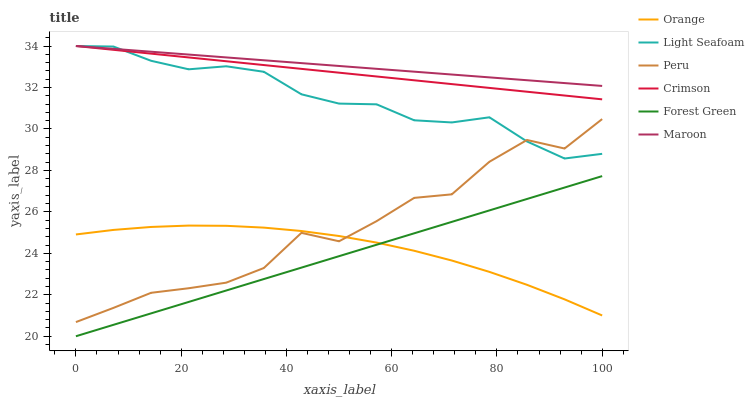Does Forest Green have the minimum area under the curve?
Answer yes or no. Yes. Does Maroon have the maximum area under the curve?
Answer yes or no. Yes. Does Crimson have the minimum area under the curve?
Answer yes or no. No. Does Crimson have the maximum area under the curve?
Answer yes or no. No. Is Maroon the smoothest?
Answer yes or no. Yes. Is Peru the roughest?
Answer yes or no. Yes. Is Crimson the smoothest?
Answer yes or no. No. Is Crimson the roughest?
Answer yes or no. No. Does Forest Green have the lowest value?
Answer yes or no. Yes. Does Crimson have the lowest value?
Answer yes or no. No. Does Light Seafoam have the highest value?
Answer yes or no. Yes. Does Forest Green have the highest value?
Answer yes or no. No. Is Orange less than Maroon?
Answer yes or no. Yes. Is Peru greater than Forest Green?
Answer yes or no. Yes. Does Crimson intersect Maroon?
Answer yes or no. Yes. Is Crimson less than Maroon?
Answer yes or no. No. Is Crimson greater than Maroon?
Answer yes or no. No. Does Orange intersect Maroon?
Answer yes or no. No. 